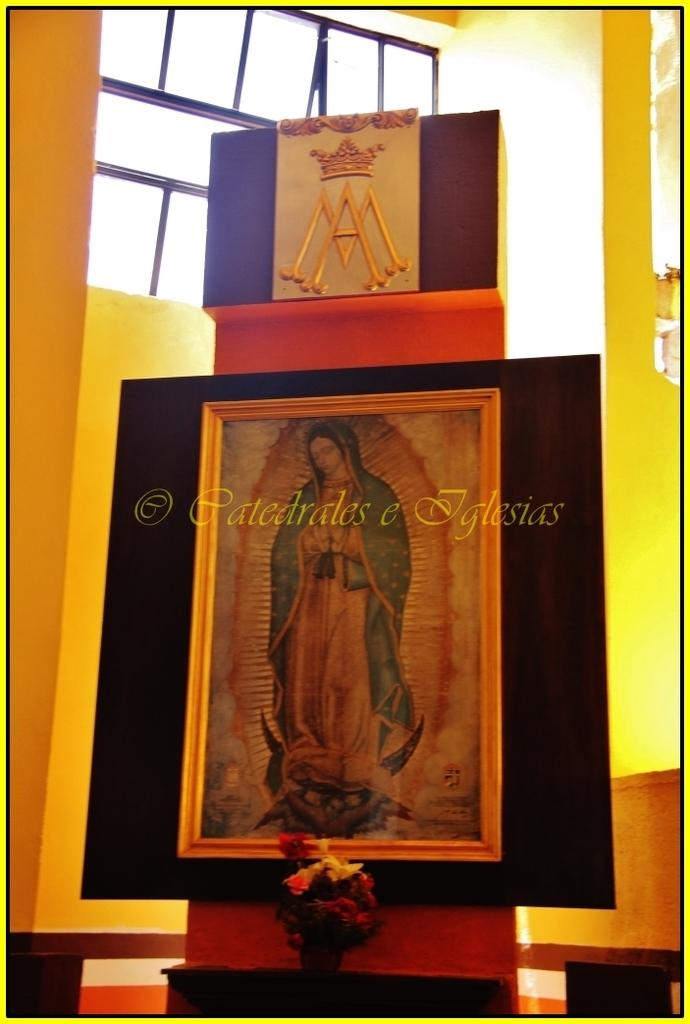<image>
Create a compact narrative representing the image presented. the name Iglesias is on the large painting of a lady 